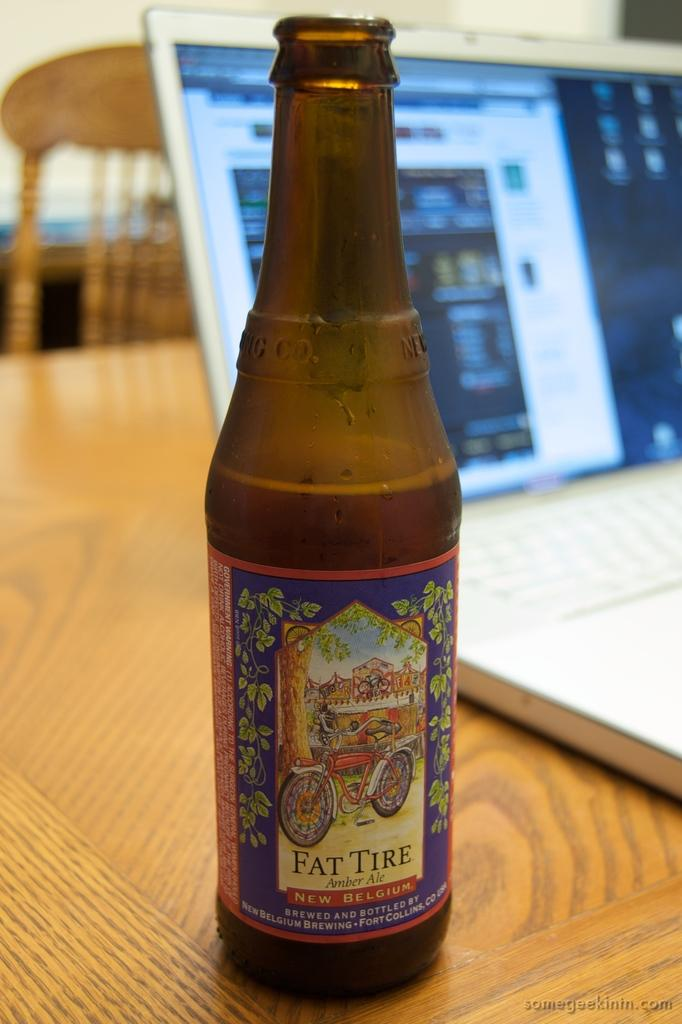Provide a one-sentence caption for the provided image. a bottle of Fat Tire Amber ale on a table. 